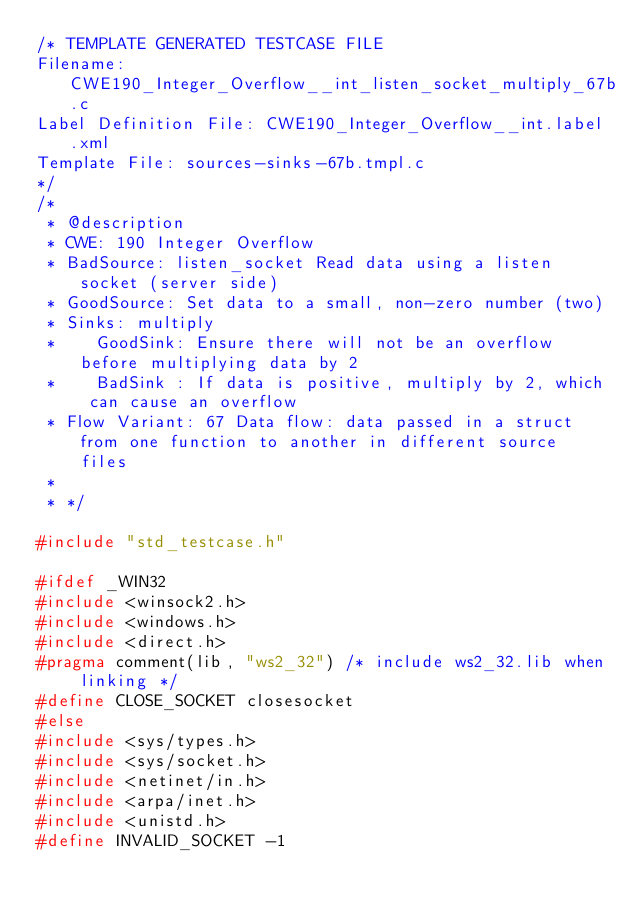Convert code to text. <code><loc_0><loc_0><loc_500><loc_500><_C_>/* TEMPLATE GENERATED TESTCASE FILE
Filename: CWE190_Integer_Overflow__int_listen_socket_multiply_67b.c
Label Definition File: CWE190_Integer_Overflow__int.label.xml
Template File: sources-sinks-67b.tmpl.c
*/
/*
 * @description
 * CWE: 190 Integer Overflow
 * BadSource: listen_socket Read data using a listen socket (server side)
 * GoodSource: Set data to a small, non-zero number (two)
 * Sinks: multiply
 *    GoodSink: Ensure there will not be an overflow before multiplying data by 2
 *    BadSink : If data is positive, multiply by 2, which can cause an overflow
 * Flow Variant: 67 Data flow: data passed in a struct from one function to another in different source files
 *
 * */

#include "std_testcase.h"

#ifdef _WIN32
#include <winsock2.h>
#include <windows.h>
#include <direct.h>
#pragma comment(lib, "ws2_32") /* include ws2_32.lib when linking */
#define CLOSE_SOCKET closesocket
#else
#include <sys/types.h>
#include <sys/socket.h>
#include <netinet/in.h>
#include <arpa/inet.h>
#include <unistd.h>
#define INVALID_SOCKET -1</code> 